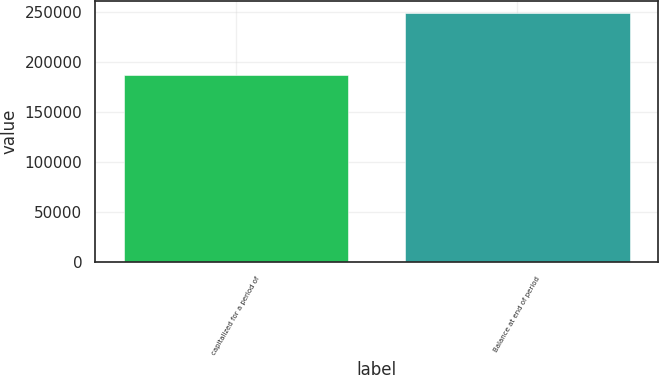Convert chart. <chart><loc_0><loc_0><loc_500><loc_500><bar_chart><fcel>capitalized for a period of<fcel>Balance at end of period<nl><fcel>187101<fcel>249033<nl></chart> 